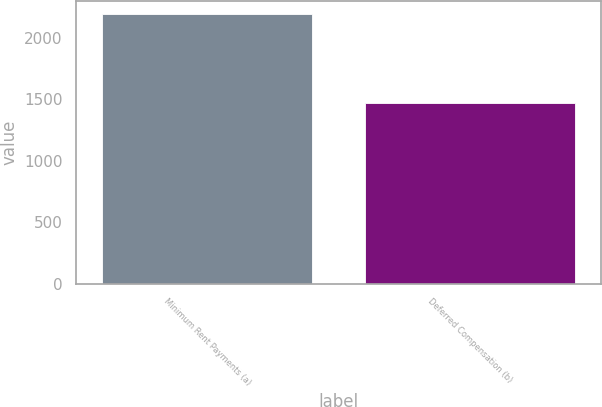Convert chart to OTSL. <chart><loc_0><loc_0><loc_500><loc_500><bar_chart><fcel>Minimum Rent Payments (a)<fcel>Deferred Compensation (b)<nl><fcel>2194<fcel>1472<nl></chart> 